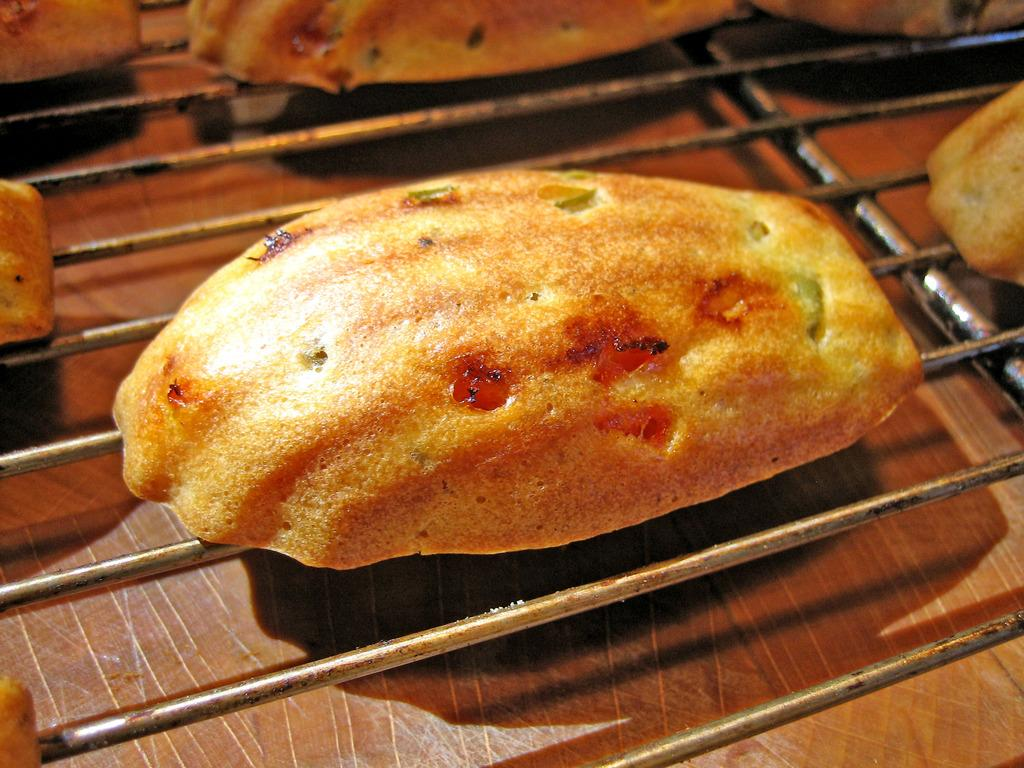What type of food is visible in the image? There is roasted bread in the image. How is the roasted bread being prepared? The roasted bread is placed on a grill. Are there any other breads visible in the image? Yes, there are more breads visible in the background of the image. What type of jewel is being used to decorate the horse in the image? There is no horse or jewel present in the image; it features roasted bread on a grill. 